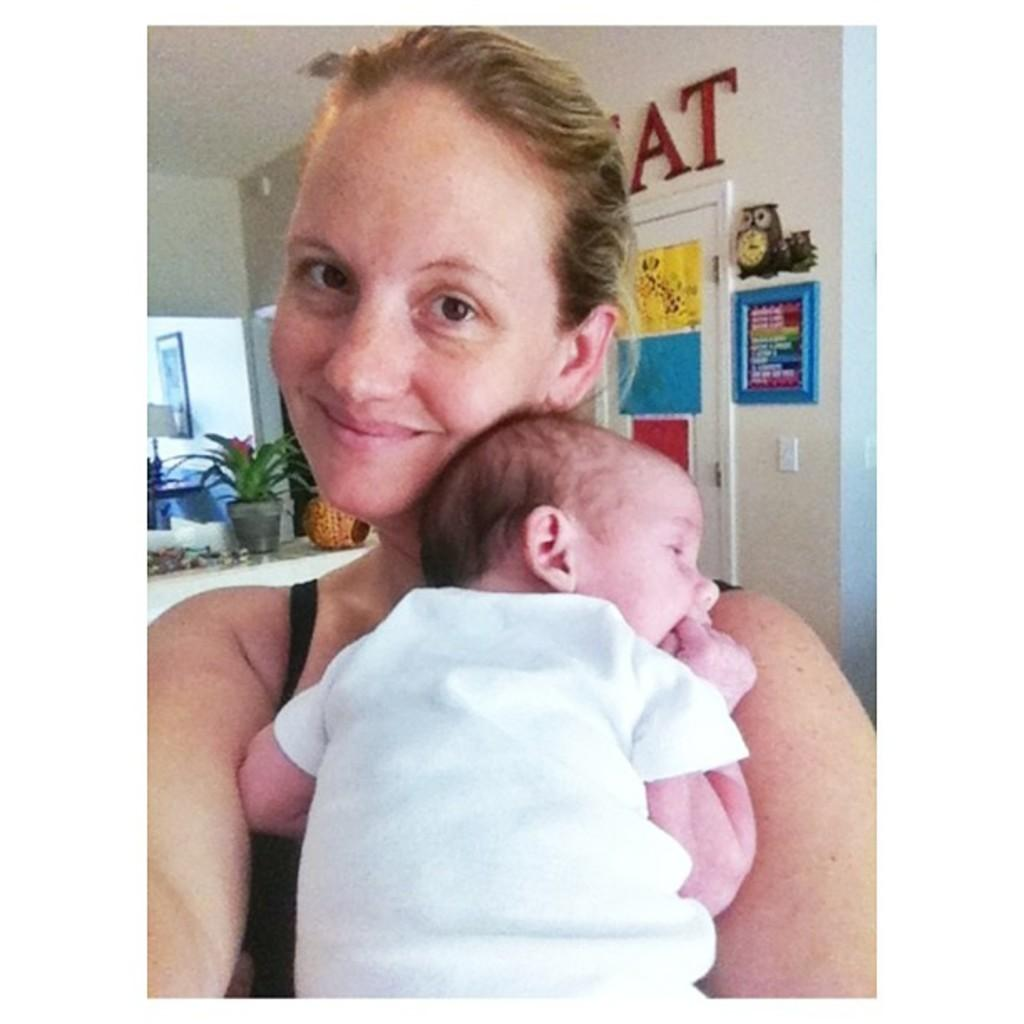Who is present in the image? There is a woman and a baby in the image. What is the woman doing? The woman is smiling. What can be seen in the background of the image? There is a wall, a house plant, a photo frame, a lamp, posters, and a door in the background of the image. Can you describe the objects in the background? There are some objects in the background of the image, but no specific details are provided. Can you see any toys floating in the river in the image? There is no river or toys present in the image. What type of jar is visible on the table in the image? There is no jar visible in the image. 